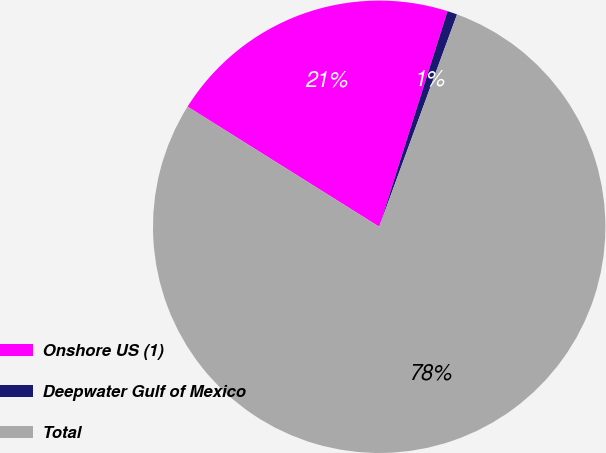Convert chart to OTSL. <chart><loc_0><loc_0><loc_500><loc_500><pie_chart><fcel>Onshore US (1)<fcel>Deepwater Gulf of Mexico<fcel>Total<nl><fcel>20.97%<fcel>0.71%<fcel>78.32%<nl></chart> 